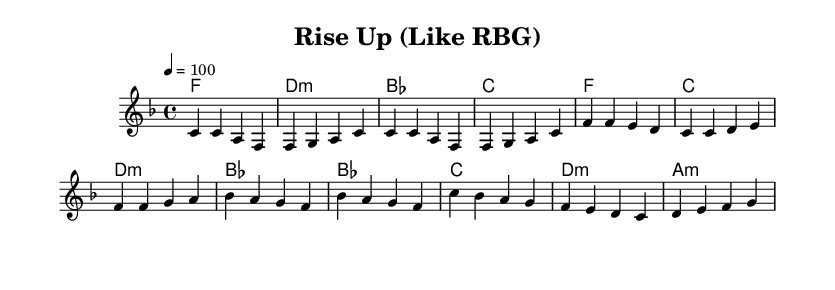What is the key signature of this music? The key signature shown in the sheet music has one flat (B♭). This indicates that the piece is in F major.
Answer: F major What is the time signature of this music? The time signature indicated at the beginning of the score is 4/4, meaning there are four beats in each measure.
Answer: 4/4 What is the tempo marking for this piece? The tempo marking is given as "4 = 100," which denotes the speed of the piece, indicating 100 beats per minute.
Answer: 100 How many measures are in the verse? By counting the measures in the verse section, there are four measures displayed, each separated by vertical lines.
Answer: 4 Which chord is played in the bridge section? The first chord in the bridge section is B♭ major, as indicated by the chord symbols set beneath the melody line.
Answer: B♭ What lyrical theme is captured in the chorus? The chorus lyrics emphasize empowerment, using the phrase "Rise up" which serves as a rallying call.
Answer: empowerment What unique musical feature distinguishes R&B in this score? R&B is often characterized by its strong backbeat which can be felt in the rhythms and is represented here with a steady 4/4 time.
Answer: backbeat 